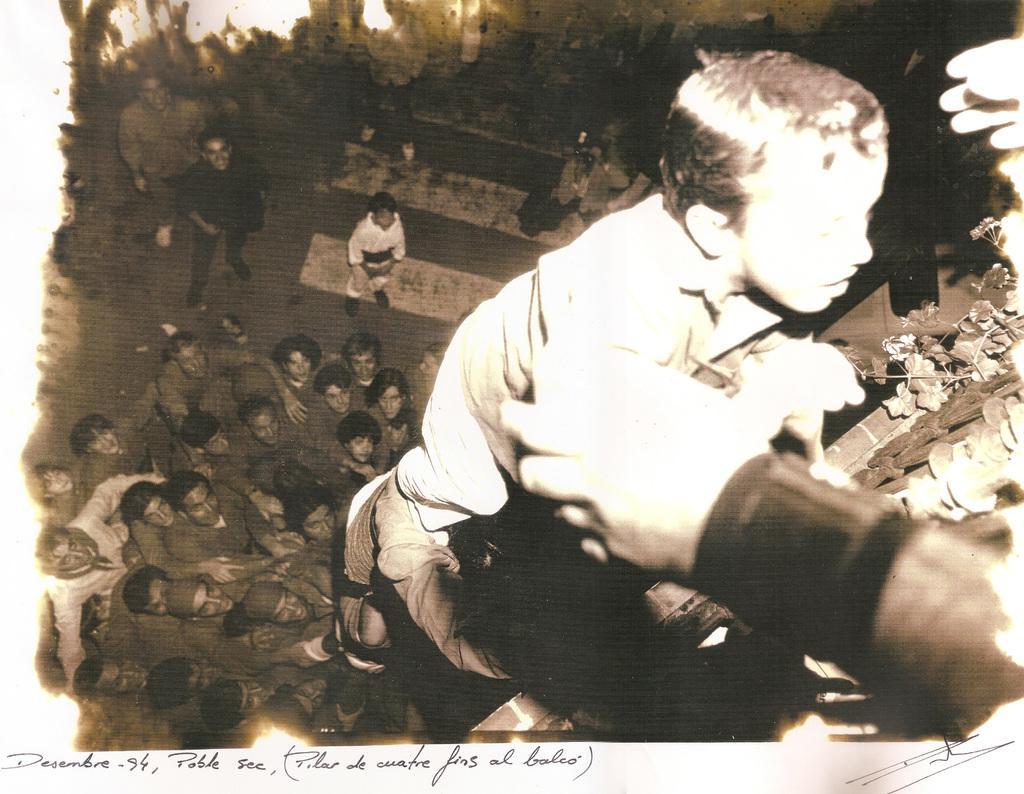In one or two sentences, can you explain what this image depicts? This is a black and white picture. Here we can see group of people. 